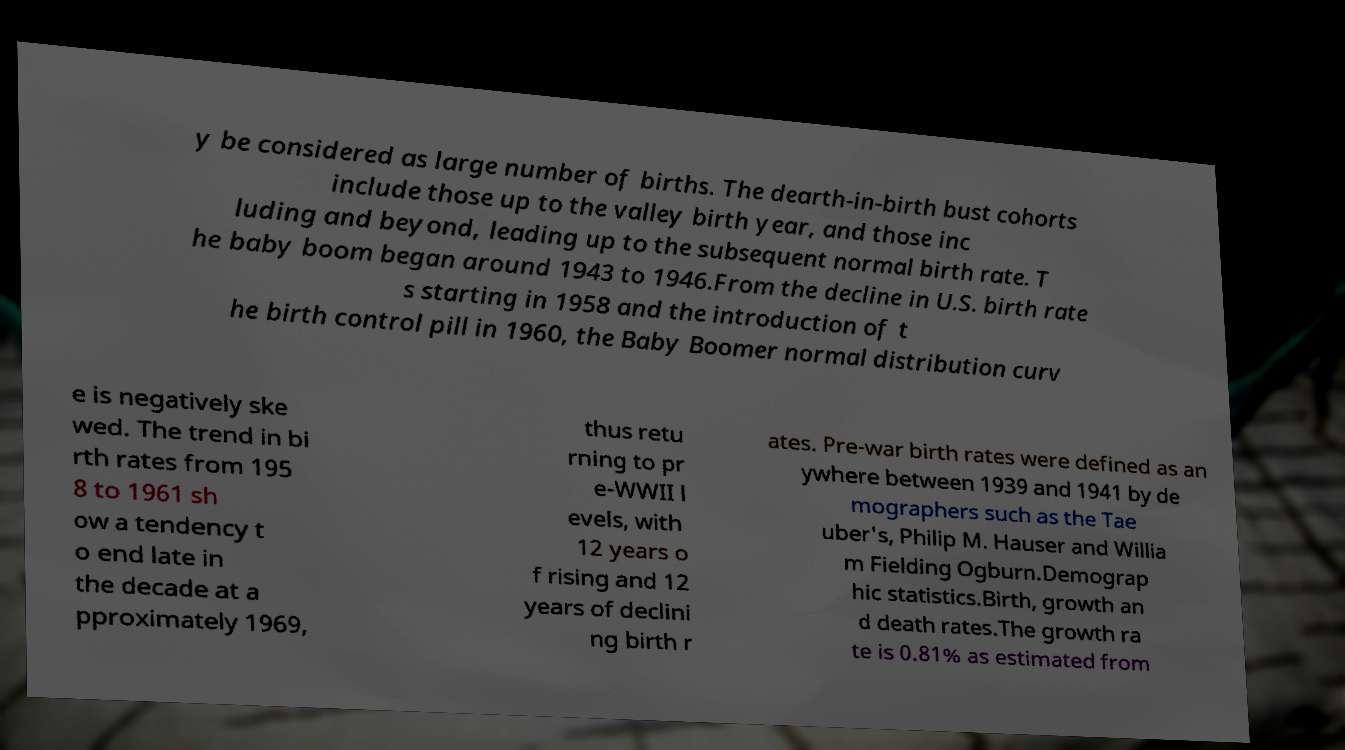What messages or text are displayed in this image? I need them in a readable, typed format. y be considered as large number of births. The dearth-in-birth bust cohorts include those up to the valley birth year, and those inc luding and beyond, leading up to the subsequent normal birth rate. T he baby boom began around 1943 to 1946.From the decline in U.S. birth rate s starting in 1958 and the introduction of t he birth control pill in 1960, the Baby Boomer normal distribution curv e is negatively ske wed. The trend in bi rth rates from 195 8 to 1961 sh ow a tendency t o end late in the decade at a pproximately 1969, thus retu rning to pr e-WWII l evels, with 12 years o f rising and 12 years of declini ng birth r ates. Pre-war birth rates were defined as an ywhere between 1939 and 1941 by de mographers such as the Tae uber's, Philip M. Hauser and Willia m Fielding Ogburn.Demograp hic statistics.Birth, growth an d death rates.The growth ra te is 0.81% as estimated from 